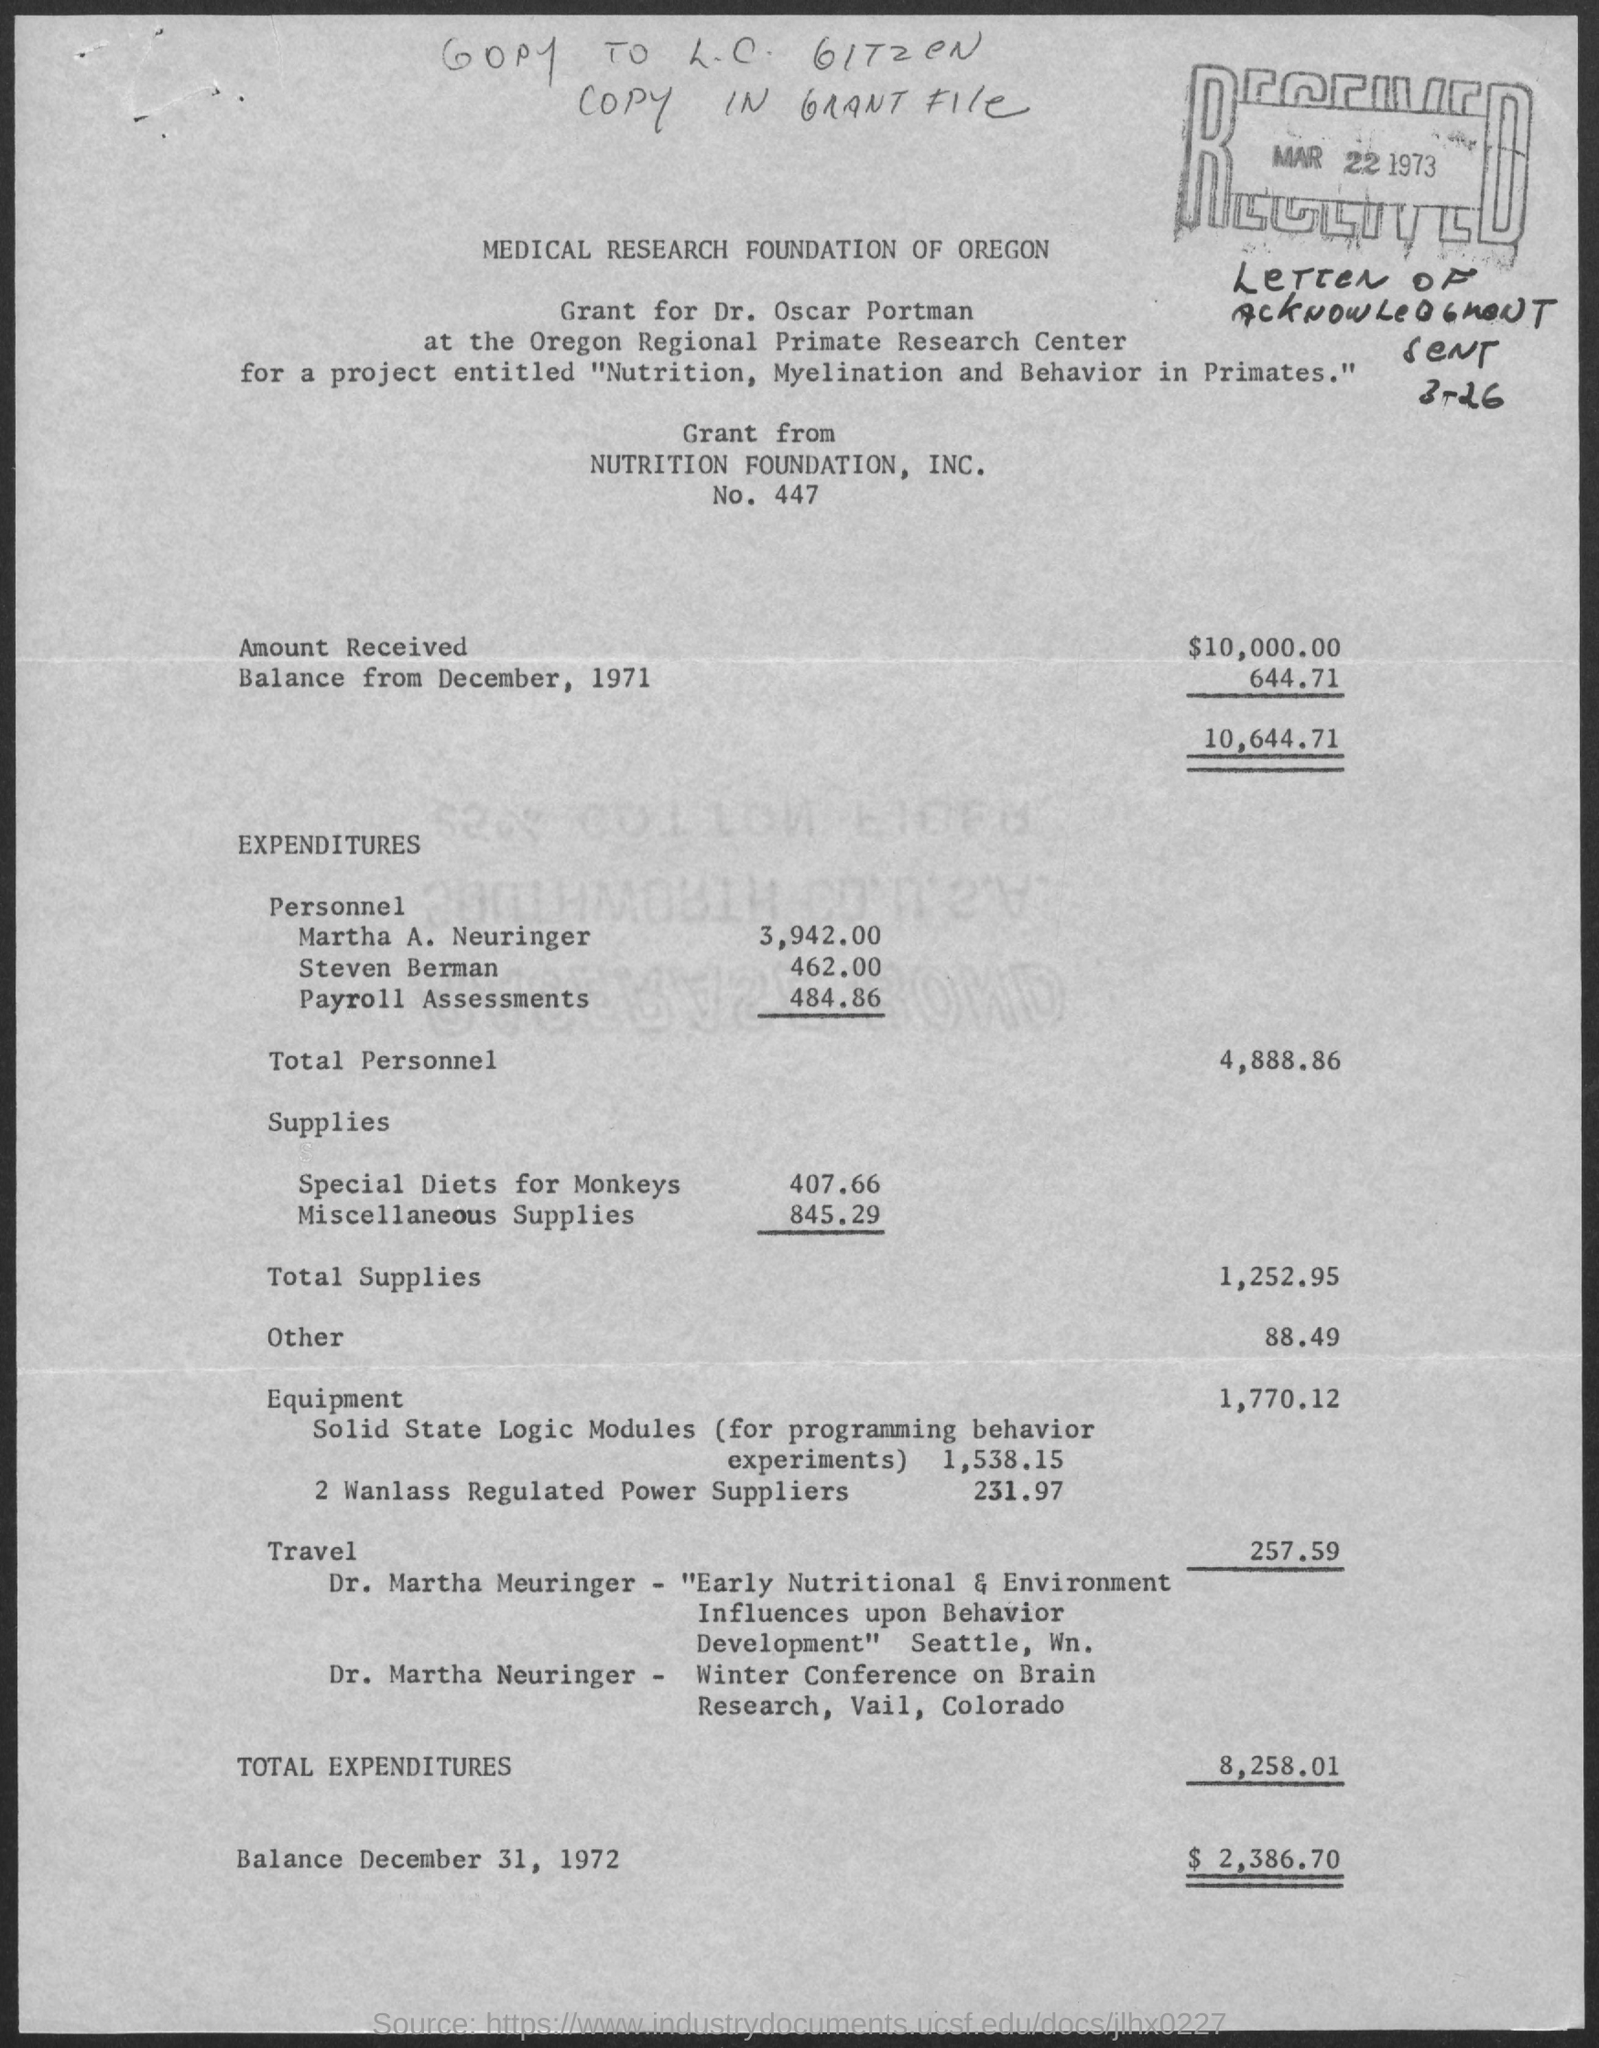Outline some significant characteristics in this image. The project titled 'Nutrition, Myelination and Behavior in Primates' has been granted a grant. The balance amount as of December 31, 1972, was $2,386.70. The total expenditures are 8,258.01. You have received a grant amount of $10,000.00. The total personnel expenditure is 4,888.86. 